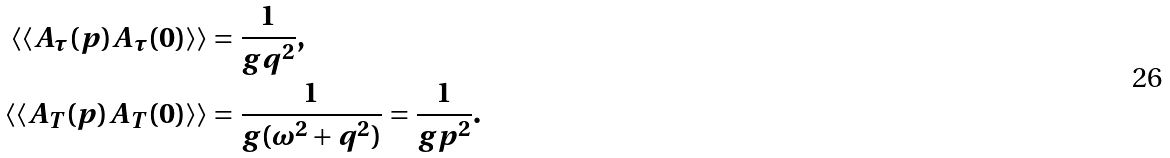<formula> <loc_0><loc_0><loc_500><loc_500>\langle \langle A _ { \tau } ( p ) A _ { \tau } ( 0 ) \rangle \rangle & = \frac { 1 } { g q ^ { 2 } } , \\ \langle \langle A _ { T } ( p ) A _ { T } ( 0 ) \rangle \rangle & = \frac { 1 } { g ( \omega ^ { 2 } + q ^ { 2 } ) } = \frac { 1 } { g p ^ { 2 } } .</formula> 